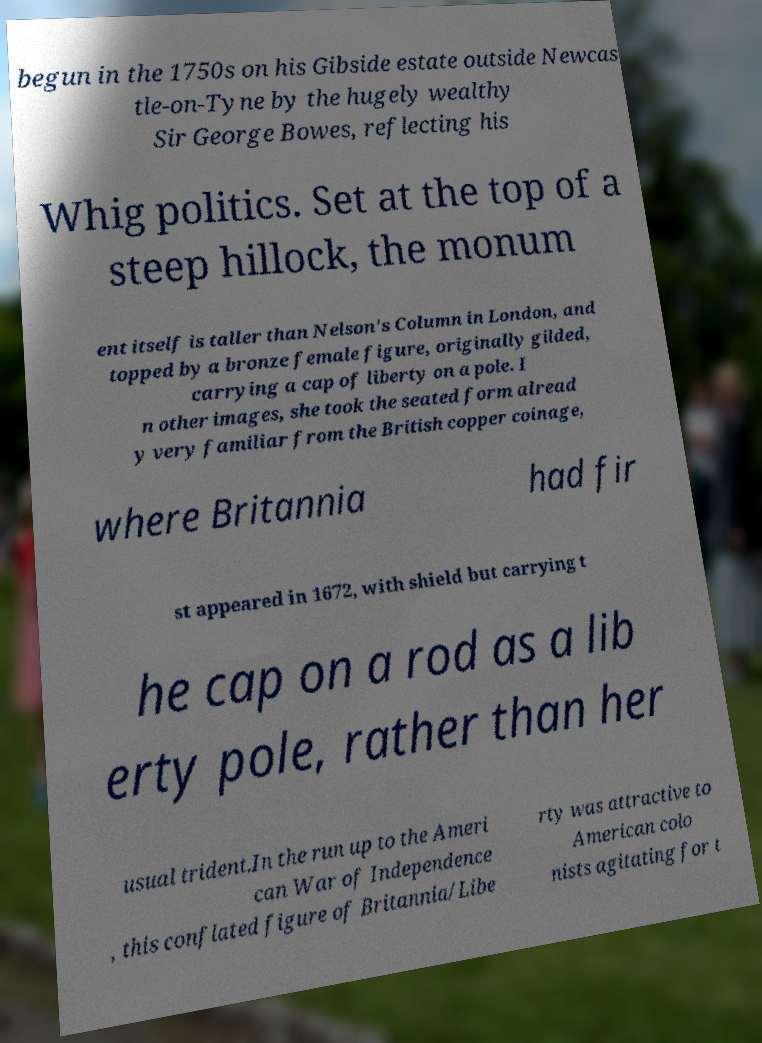Could you extract and type out the text from this image? begun in the 1750s on his Gibside estate outside Newcas tle-on-Tyne by the hugely wealthy Sir George Bowes, reflecting his Whig politics. Set at the top of a steep hillock, the monum ent itself is taller than Nelson's Column in London, and topped by a bronze female figure, originally gilded, carrying a cap of liberty on a pole. I n other images, she took the seated form alread y very familiar from the British copper coinage, where Britannia had fir st appeared in 1672, with shield but carrying t he cap on a rod as a lib erty pole, rather than her usual trident.In the run up to the Ameri can War of Independence , this conflated figure of Britannia/Libe rty was attractive to American colo nists agitating for t 